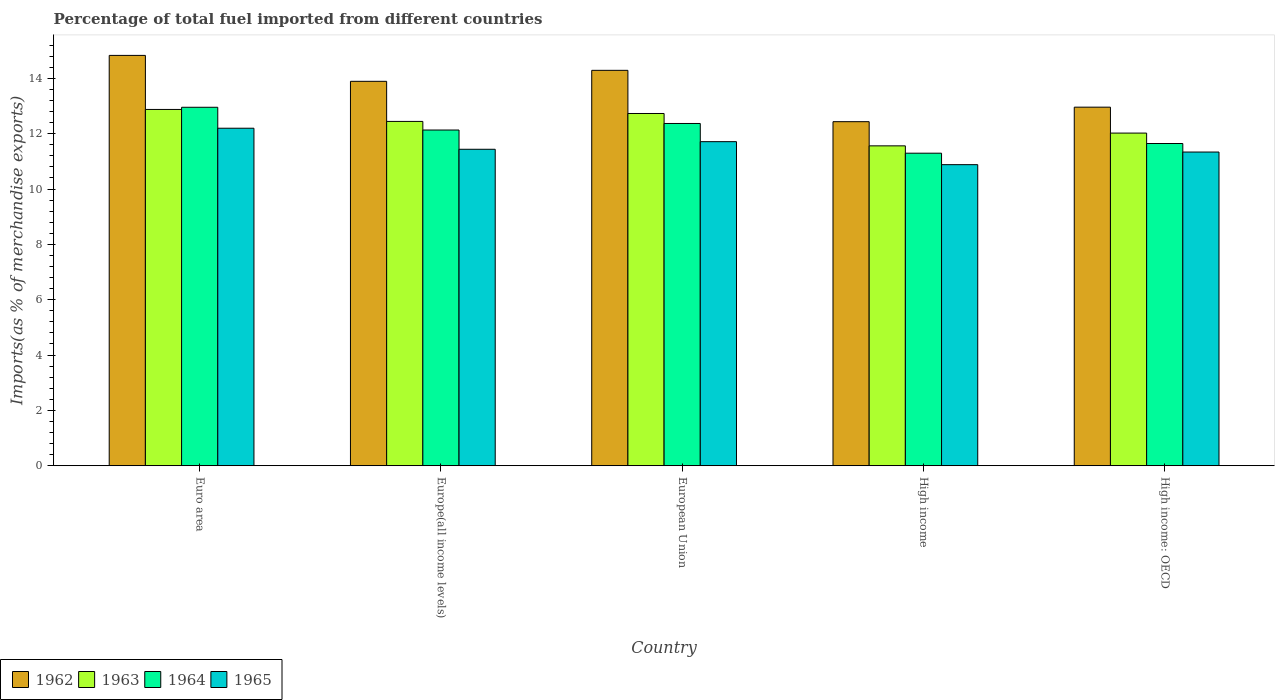How many groups of bars are there?
Make the answer very short. 5. Are the number of bars per tick equal to the number of legend labels?
Offer a terse response. Yes. What is the label of the 1st group of bars from the left?
Give a very brief answer. Euro area. In how many cases, is the number of bars for a given country not equal to the number of legend labels?
Provide a short and direct response. 0. What is the percentage of imports to different countries in 1964 in European Union?
Provide a succinct answer. 12.37. Across all countries, what is the maximum percentage of imports to different countries in 1965?
Provide a succinct answer. 12.2. Across all countries, what is the minimum percentage of imports to different countries in 1962?
Your response must be concise. 12.43. In which country was the percentage of imports to different countries in 1963 maximum?
Keep it short and to the point. Euro area. In which country was the percentage of imports to different countries in 1963 minimum?
Provide a short and direct response. High income. What is the total percentage of imports to different countries in 1964 in the graph?
Your response must be concise. 60.39. What is the difference between the percentage of imports to different countries in 1962 in European Union and that in High income: OECD?
Provide a succinct answer. 1.33. What is the difference between the percentage of imports to different countries in 1964 in Euro area and the percentage of imports to different countries in 1965 in High income: OECD?
Keep it short and to the point. 1.62. What is the average percentage of imports to different countries in 1962 per country?
Provide a succinct answer. 13.68. What is the difference between the percentage of imports to different countries of/in 1964 and percentage of imports to different countries of/in 1965 in High income: OECD?
Keep it short and to the point. 0.31. In how many countries, is the percentage of imports to different countries in 1963 greater than 12.4 %?
Your answer should be very brief. 3. What is the ratio of the percentage of imports to different countries in 1963 in High income to that in High income: OECD?
Your response must be concise. 0.96. What is the difference between the highest and the second highest percentage of imports to different countries in 1962?
Offer a terse response. -0.94. What is the difference between the highest and the lowest percentage of imports to different countries in 1965?
Make the answer very short. 1.32. What does the 3rd bar from the left in Euro area represents?
Your response must be concise. 1964. What does the 1st bar from the right in High income: OECD represents?
Provide a succinct answer. 1965. How many bars are there?
Ensure brevity in your answer.  20. How many countries are there in the graph?
Make the answer very short. 5. Does the graph contain any zero values?
Provide a short and direct response. No. Does the graph contain grids?
Ensure brevity in your answer.  No. Where does the legend appear in the graph?
Your response must be concise. Bottom left. How many legend labels are there?
Ensure brevity in your answer.  4. What is the title of the graph?
Your response must be concise. Percentage of total fuel imported from different countries. Does "2001" appear as one of the legend labels in the graph?
Offer a very short reply. No. What is the label or title of the Y-axis?
Your answer should be compact. Imports(as % of merchandise exports). What is the Imports(as % of merchandise exports) of 1962 in Euro area?
Ensure brevity in your answer.  14.83. What is the Imports(as % of merchandise exports) of 1963 in Euro area?
Ensure brevity in your answer.  12.88. What is the Imports(as % of merchandise exports) in 1964 in Euro area?
Keep it short and to the point. 12.95. What is the Imports(as % of merchandise exports) of 1965 in Euro area?
Your answer should be compact. 12.2. What is the Imports(as % of merchandise exports) in 1962 in Europe(all income levels)?
Keep it short and to the point. 13.89. What is the Imports(as % of merchandise exports) in 1963 in Europe(all income levels)?
Provide a short and direct response. 12.44. What is the Imports(as % of merchandise exports) in 1964 in Europe(all income levels)?
Give a very brief answer. 12.13. What is the Imports(as % of merchandise exports) in 1965 in Europe(all income levels)?
Your answer should be very brief. 11.44. What is the Imports(as % of merchandise exports) in 1962 in European Union?
Your answer should be very brief. 14.29. What is the Imports(as % of merchandise exports) in 1963 in European Union?
Make the answer very short. 12.73. What is the Imports(as % of merchandise exports) in 1964 in European Union?
Give a very brief answer. 12.37. What is the Imports(as % of merchandise exports) of 1965 in European Union?
Make the answer very short. 11.71. What is the Imports(as % of merchandise exports) of 1962 in High income?
Make the answer very short. 12.43. What is the Imports(as % of merchandise exports) of 1963 in High income?
Offer a terse response. 11.56. What is the Imports(as % of merchandise exports) in 1964 in High income?
Offer a terse response. 11.29. What is the Imports(as % of merchandise exports) in 1965 in High income?
Give a very brief answer. 10.88. What is the Imports(as % of merchandise exports) in 1962 in High income: OECD?
Provide a short and direct response. 12.96. What is the Imports(as % of merchandise exports) in 1963 in High income: OECD?
Your answer should be compact. 12.02. What is the Imports(as % of merchandise exports) in 1964 in High income: OECD?
Make the answer very short. 11.64. What is the Imports(as % of merchandise exports) in 1965 in High income: OECD?
Offer a terse response. 11.34. Across all countries, what is the maximum Imports(as % of merchandise exports) in 1962?
Make the answer very short. 14.83. Across all countries, what is the maximum Imports(as % of merchandise exports) of 1963?
Your answer should be compact. 12.88. Across all countries, what is the maximum Imports(as % of merchandise exports) in 1964?
Give a very brief answer. 12.95. Across all countries, what is the maximum Imports(as % of merchandise exports) of 1965?
Keep it short and to the point. 12.2. Across all countries, what is the minimum Imports(as % of merchandise exports) of 1962?
Your response must be concise. 12.43. Across all countries, what is the minimum Imports(as % of merchandise exports) of 1963?
Keep it short and to the point. 11.56. Across all countries, what is the minimum Imports(as % of merchandise exports) of 1964?
Ensure brevity in your answer.  11.29. Across all countries, what is the minimum Imports(as % of merchandise exports) of 1965?
Give a very brief answer. 10.88. What is the total Imports(as % of merchandise exports) of 1962 in the graph?
Make the answer very short. 68.4. What is the total Imports(as % of merchandise exports) of 1963 in the graph?
Provide a short and direct response. 61.63. What is the total Imports(as % of merchandise exports) in 1964 in the graph?
Offer a terse response. 60.39. What is the total Imports(as % of merchandise exports) in 1965 in the graph?
Ensure brevity in your answer.  57.56. What is the difference between the Imports(as % of merchandise exports) of 1962 in Euro area and that in Europe(all income levels)?
Your answer should be compact. 0.94. What is the difference between the Imports(as % of merchandise exports) of 1963 in Euro area and that in Europe(all income levels)?
Ensure brevity in your answer.  0.43. What is the difference between the Imports(as % of merchandise exports) in 1964 in Euro area and that in Europe(all income levels)?
Give a very brief answer. 0.82. What is the difference between the Imports(as % of merchandise exports) of 1965 in Euro area and that in Europe(all income levels)?
Keep it short and to the point. 0.76. What is the difference between the Imports(as % of merchandise exports) in 1962 in Euro area and that in European Union?
Ensure brevity in your answer.  0.54. What is the difference between the Imports(as % of merchandise exports) of 1963 in Euro area and that in European Union?
Provide a succinct answer. 0.15. What is the difference between the Imports(as % of merchandise exports) of 1964 in Euro area and that in European Union?
Offer a very short reply. 0.59. What is the difference between the Imports(as % of merchandise exports) in 1965 in Euro area and that in European Union?
Offer a very short reply. 0.49. What is the difference between the Imports(as % of merchandise exports) of 1962 in Euro area and that in High income?
Your answer should be compact. 2.4. What is the difference between the Imports(as % of merchandise exports) in 1963 in Euro area and that in High income?
Ensure brevity in your answer.  1.32. What is the difference between the Imports(as % of merchandise exports) of 1964 in Euro area and that in High income?
Provide a succinct answer. 1.66. What is the difference between the Imports(as % of merchandise exports) of 1965 in Euro area and that in High income?
Offer a terse response. 1.32. What is the difference between the Imports(as % of merchandise exports) of 1962 in Euro area and that in High income: OECD?
Make the answer very short. 1.87. What is the difference between the Imports(as % of merchandise exports) of 1963 in Euro area and that in High income: OECD?
Your response must be concise. 0.85. What is the difference between the Imports(as % of merchandise exports) in 1964 in Euro area and that in High income: OECD?
Ensure brevity in your answer.  1.31. What is the difference between the Imports(as % of merchandise exports) of 1965 in Euro area and that in High income: OECD?
Offer a terse response. 0.86. What is the difference between the Imports(as % of merchandise exports) of 1962 in Europe(all income levels) and that in European Union?
Offer a very short reply. -0.4. What is the difference between the Imports(as % of merchandise exports) in 1963 in Europe(all income levels) and that in European Union?
Your answer should be compact. -0.29. What is the difference between the Imports(as % of merchandise exports) of 1964 in Europe(all income levels) and that in European Union?
Provide a short and direct response. -0.24. What is the difference between the Imports(as % of merchandise exports) of 1965 in Europe(all income levels) and that in European Union?
Your response must be concise. -0.27. What is the difference between the Imports(as % of merchandise exports) in 1962 in Europe(all income levels) and that in High income?
Give a very brief answer. 1.46. What is the difference between the Imports(as % of merchandise exports) of 1963 in Europe(all income levels) and that in High income?
Your answer should be compact. 0.88. What is the difference between the Imports(as % of merchandise exports) of 1964 in Europe(all income levels) and that in High income?
Provide a succinct answer. 0.84. What is the difference between the Imports(as % of merchandise exports) in 1965 in Europe(all income levels) and that in High income?
Ensure brevity in your answer.  0.56. What is the difference between the Imports(as % of merchandise exports) in 1962 in Europe(all income levels) and that in High income: OECD?
Keep it short and to the point. 0.93. What is the difference between the Imports(as % of merchandise exports) in 1963 in Europe(all income levels) and that in High income: OECD?
Ensure brevity in your answer.  0.42. What is the difference between the Imports(as % of merchandise exports) of 1964 in Europe(all income levels) and that in High income: OECD?
Keep it short and to the point. 0.49. What is the difference between the Imports(as % of merchandise exports) in 1965 in Europe(all income levels) and that in High income: OECD?
Offer a terse response. 0.1. What is the difference between the Imports(as % of merchandise exports) of 1962 in European Union and that in High income?
Offer a very short reply. 1.86. What is the difference between the Imports(as % of merchandise exports) of 1963 in European Union and that in High income?
Your answer should be very brief. 1.17. What is the difference between the Imports(as % of merchandise exports) in 1964 in European Union and that in High income?
Give a very brief answer. 1.07. What is the difference between the Imports(as % of merchandise exports) of 1965 in European Union and that in High income?
Keep it short and to the point. 0.83. What is the difference between the Imports(as % of merchandise exports) in 1962 in European Union and that in High income: OECD?
Make the answer very short. 1.33. What is the difference between the Imports(as % of merchandise exports) of 1963 in European Union and that in High income: OECD?
Keep it short and to the point. 0.71. What is the difference between the Imports(as % of merchandise exports) in 1964 in European Union and that in High income: OECD?
Offer a very short reply. 0.72. What is the difference between the Imports(as % of merchandise exports) in 1965 in European Union and that in High income: OECD?
Provide a succinct answer. 0.38. What is the difference between the Imports(as % of merchandise exports) of 1962 in High income and that in High income: OECD?
Provide a short and direct response. -0.52. What is the difference between the Imports(as % of merchandise exports) in 1963 in High income and that in High income: OECD?
Your answer should be very brief. -0.46. What is the difference between the Imports(as % of merchandise exports) in 1964 in High income and that in High income: OECD?
Keep it short and to the point. -0.35. What is the difference between the Imports(as % of merchandise exports) in 1965 in High income and that in High income: OECD?
Give a very brief answer. -0.46. What is the difference between the Imports(as % of merchandise exports) of 1962 in Euro area and the Imports(as % of merchandise exports) of 1963 in Europe(all income levels)?
Provide a short and direct response. 2.39. What is the difference between the Imports(as % of merchandise exports) of 1962 in Euro area and the Imports(as % of merchandise exports) of 1964 in Europe(all income levels)?
Ensure brevity in your answer.  2.7. What is the difference between the Imports(as % of merchandise exports) of 1962 in Euro area and the Imports(as % of merchandise exports) of 1965 in Europe(all income levels)?
Provide a succinct answer. 3.39. What is the difference between the Imports(as % of merchandise exports) in 1963 in Euro area and the Imports(as % of merchandise exports) in 1964 in Europe(all income levels)?
Your answer should be very brief. 0.74. What is the difference between the Imports(as % of merchandise exports) in 1963 in Euro area and the Imports(as % of merchandise exports) in 1965 in Europe(all income levels)?
Your answer should be very brief. 1.44. What is the difference between the Imports(as % of merchandise exports) of 1964 in Euro area and the Imports(as % of merchandise exports) of 1965 in Europe(all income levels)?
Ensure brevity in your answer.  1.52. What is the difference between the Imports(as % of merchandise exports) in 1962 in Euro area and the Imports(as % of merchandise exports) in 1963 in European Union?
Offer a very short reply. 2.1. What is the difference between the Imports(as % of merchandise exports) in 1962 in Euro area and the Imports(as % of merchandise exports) in 1964 in European Union?
Your answer should be very brief. 2.46. What is the difference between the Imports(as % of merchandise exports) of 1962 in Euro area and the Imports(as % of merchandise exports) of 1965 in European Union?
Your response must be concise. 3.12. What is the difference between the Imports(as % of merchandise exports) of 1963 in Euro area and the Imports(as % of merchandise exports) of 1964 in European Union?
Provide a short and direct response. 0.51. What is the difference between the Imports(as % of merchandise exports) in 1963 in Euro area and the Imports(as % of merchandise exports) in 1965 in European Union?
Offer a terse response. 1.16. What is the difference between the Imports(as % of merchandise exports) in 1964 in Euro area and the Imports(as % of merchandise exports) in 1965 in European Union?
Your answer should be very brief. 1.24. What is the difference between the Imports(as % of merchandise exports) in 1962 in Euro area and the Imports(as % of merchandise exports) in 1963 in High income?
Ensure brevity in your answer.  3.27. What is the difference between the Imports(as % of merchandise exports) of 1962 in Euro area and the Imports(as % of merchandise exports) of 1964 in High income?
Your answer should be very brief. 3.53. What is the difference between the Imports(as % of merchandise exports) of 1962 in Euro area and the Imports(as % of merchandise exports) of 1965 in High income?
Ensure brevity in your answer.  3.95. What is the difference between the Imports(as % of merchandise exports) in 1963 in Euro area and the Imports(as % of merchandise exports) in 1964 in High income?
Make the answer very short. 1.58. What is the difference between the Imports(as % of merchandise exports) in 1963 in Euro area and the Imports(as % of merchandise exports) in 1965 in High income?
Give a very brief answer. 2. What is the difference between the Imports(as % of merchandise exports) in 1964 in Euro area and the Imports(as % of merchandise exports) in 1965 in High income?
Offer a terse response. 2.07. What is the difference between the Imports(as % of merchandise exports) in 1962 in Euro area and the Imports(as % of merchandise exports) in 1963 in High income: OECD?
Give a very brief answer. 2.81. What is the difference between the Imports(as % of merchandise exports) of 1962 in Euro area and the Imports(as % of merchandise exports) of 1964 in High income: OECD?
Offer a terse response. 3.18. What is the difference between the Imports(as % of merchandise exports) in 1962 in Euro area and the Imports(as % of merchandise exports) in 1965 in High income: OECD?
Offer a very short reply. 3.49. What is the difference between the Imports(as % of merchandise exports) in 1963 in Euro area and the Imports(as % of merchandise exports) in 1964 in High income: OECD?
Ensure brevity in your answer.  1.23. What is the difference between the Imports(as % of merchandise exports) in 1963 in Euro area and the Imports(as % of merchandise exports) in 1965 in High income: OECD?
Offer a terse response. 1.54. What is the difference between the Imports(as % of merchandise exports) in 1964 in Euro area and the Imports(as % of merchandise exports) in 1965 in High income: OECD?
Offer a terse response. 1.62. What is the difference between the Imports(as % of merchandise exports) of 1962 in Europe(all income levels) and the Imports(as % of merchandise exports) of 1963 in European Union?
Provide a short and direct response. 1.16. What is the difference between the Imports(as % of merchandise exports) of 1962 in Europe(all income levels) and the Imports(as % of merchandise exports) of 1964 in European Union?
Ensure brevity in your answer.  1.52. What is the difference between the Imports(as % of merchandise exports) in 1962 in Europe(all income levels) and the Imports(as % of merchandise exports) in 1965 in European Union?
Offer a very short reply. 2.18. What is the difference between the Imports(as % of merchandise exports) of 1963 in Europe(all income levels) and the Imports(as % of merchandise exports) of 1964 in European Union?
Offer a very short reply. 0.07. What is the difference between the Imports(as % of merchandise exports) in 1963 in Europe(all income levels) and the Imports(as % of merchandise exports) in 1965 in European Union?
Keep it short and to the point. 0.73. What is the difference between the Imports(as % of merchandise exports) in 1964 in Europe(all income levels) and the Imports(as % of merchandise exports) in 1965 in European Union?
Your answer should be very brief. 0.42. What is the difference between the Imports(as % of merchandise exports) of 1962 in Europe(all income levels) and the Imports(as % of merchandise exports) of 1963 in High income?
Your answer should be very brief. 2.33. What is the difference between the Imports(as % of merchandise exports) of 1962 in Europe(all income levels) and the Imports(as % of merchandise exports) of 1964 in High income?
Offer a very short reply. 2.6. What is the difference between the Imports(as % of merchandise exports) of 1962 in Europe(all income levels) and the Imports(as % of merchandise exports) of 1965 in High income?
Provide a short and direct response. 3.01. What is the difference between the Imports(as % of merchandise exports) in 1963 in Europe(all income levels) and the Imports(as % of merchandise exports) in 1964 in High income?
Ensure brevity in your answer.  1.15. What is the difference between the Imports(as % of merchandise exports) of 1963 in Europe(all income levels) and the Imports(as % of merchandise exports) of 1965 in High income?
Your answer should be compact. 1.56. What is the difference between the Imports(as % of merchandise exports) in 1964 in Europe(all income levels) and the Imports(as % of merchandise exports) in 1965 in High income?
Provide a succinct answer. 1.25. What is the difference between the Imports(as % of merchandise exports) in 1962 in Europe(all income levels) and the Imports(as % of merchandise exports) in 1963 in High income: OECD?
Ensure brevity in your answer.  1.87. What is the difference between the Imports(as % of merchandise exports) in 1962 in Europe(all income levels) and the Imports(as % of merchandise exports) in 1964 in High income: OECD?
Provide a short and direct response. 2.25. What is the difference between the Imports(as % of merchandise exports) of 1962 in Europe(all income levels) and the Imports(as % of merchandise exports) of 1965 in High income: OECD?
Give a very brief answer. 2.56. What is the difference between the Imports(as % of merchandise exports) of 1963 in Europe(all income levels) and the Imports(as % of merchandise exports) of 1964 in High income: OECD?
Keep it short and to the point. 0.8. What is the difference between the Imports(as % of merchandise exports) in 1963 in Europe(all income levels) and the Imports(as % of merchandise exports) in 1965 in High income: OECD?
Make the answer very short. 1.11. What is the difference between the Imports(as % of merchandise exports) of 1964 in Europe(all income levels) and the Imports(as % of merchandise exports) of 1965 in High income: OECD?
Make the answer very short. 0.8. What is the difference between the Imports(as % of merchandise exports) in 1962 in European Union and the Imports(as % of merchandise exports) in 1963 in High income?
Provide a succinct answer. 2.73. What is the difference between the Imports(as % of merchandise exports) in 1962 in European Union and the Imports(as % of merchandise exports) in 1964 in High income?
Ensure brevity in your answer.  2.99. What is the difference between the Imports(as % of merchandise exports) in 1962 in European Union and the Imports(as % of merchandise exports) in 1965 in High income?
Your answer should be very brief. 3.41. What is the difference between the Imports(as % of merchandise exports) in 1963 in European Union and the Imports(as % of merchandise exports) in 1964 in High income?
Make the answer very short. 1.43. What is the difference between the Imports(as % of merchandise exports) in 1963 in European Union and the Imports(as % of merchandise exports) in 1965 in High income?
Your answer should be compact. 1.85. What is the difference between the Imports(as % of merchandise exports) of 1964 in European Union and the Imports(as % of merchandise exports) of 1965 in High income?
Give a very brief answer. 1.49. What is the difference between the Imports(as % of merchandise exports) in 1962 in European Union and the Imports(as % of merchandise exports) in 1963 in High income: OECD?
Give a very brief answer. 2.27. What is the difference between the Imports(as % of merchandise exports) of 1962 in European Union and the Imports(as % of merchandise exports) of 1964 in High income: OECD?
Your answer should be compact. 2.64. What is the difference between the Imports(as % of merchandise exports) in 1962 in European Union and the Imports(as % of merchandise exports) in 1965 in High income: OECD?
Make the answer very short. 2.95. What is the difference between the Imports(as % of merchandise exports) in 1963 in European Union and the Imports(as % of merchandise exports) in 1964 in High income: OECD?
Ensure brevity in your answer.  1.08. What is the difference between the Imports(as % of merchandise exports) of 1963 in European Union and the Imports(as % of merchandise exports) of 1965 in High income: OECD?
Your response must be concise. 1.39. What is the difference between the Imports(as % of merchandise exports) of 1964 in European Union and the Imports(as % of merchandise exports) of 1965 in High income: OECD?
Keep it short and to the point. 1.03. What is the difference between the Imports(as % of merchandise exports) in 1962 in High income and the Imports(as % of merchandise exports) in 1963 in High income: OECD?
Provide a short and direct response. 0.41. What is the difference between the Imports(as % of merchandise exports) in 1962 in High income and the Imports(as % of merchandise exports) in 1964 in High income: OECD?
Your answer should be compact. 0.79. What is the difference between the Imports(as % of merchandise exports) of 1962 in High income and the Imports(as % of merchandise exports) of 1965 in High income: OECD?
Offer a terse response. 1.1. What is the difference between the Imports(as % of merchandise exports) of 1963 in High income and the Imports(as % of merchandise exports) of 1964 in High income: OECD?
Your response must be concise. -0.09. What is the difference between the Imports(as % of merchandise exports) of 1963 in High income and the Imports(as % of merchandise exports) of 1965 in High income: OECD?
Provide a succinct answer. 0.22. What is the difference between the Imports(as % of merchandise exports) in 1964 in High income and the Imports(as % of merchandise exports) in 1965 in High income: OECD?
Your answer should be very brief. -0.04. What is the average Imports(as % of merchandise exports) in 1962 per country?
Make the answer very short. 13.68. What is the average Imports(as % of merchandise exports) of 1963 per country?
Provide a short and direct response. 12.33. What is the average Imports(as % of merchandise exports) of 1964 per country?
Offer a very short reply. 12.08. What is the average Imports(as % of merchandise exports) in 1965 per country?
Provide a short and direct response. 11.51. What is the difference between the Imports(as % of merchandise exports) in 1962 and Imports(as % of merchandise exports) in 1963 in Euro area?
Ensure brevity in your answer.  1.95. What is the difference between the Imports(as % of merchandise exports) in 1962 and Imports(as % of merchandise exports) in 1964 in Euro area?
Your answer should be compact. 1.87. What is the difference between the Imports(as % of merchandise exports) of 1962 and Imports(as % of merchandise exports) of 1965 in Euro area?
Offer a very short reply. 2.63. What is the difference between the Imports(as % of merchandise exports) of 1963 and Imports(as % of merchandise exports) of 1964 in Euro area?
Offer a terse response. -0.08. What is the difference between the Imports(as % of merchandise exports) in 1963 and Imports(as % of merchandise exports) in 1965 in Euro area?
Offer a very short reply. 0.68. What is the difference between the Imports(as % of merchandise exports) of 1964 and Imports(as % of merchandise exports) of 1965 in Euro area?
Make the answer very short. 0.76. What is the difference between the Imports(as % of merchandise exports) in 1962 and Imports(as % of merchandise exports) in 1963 in Europe(all income levels)?
Offer a very short reply. 1.45. What is the difference between the Imports(as % of merchandise exports) of 1962 and Imports(as % of merchandise exports) of 1964 in Europe(all income levels)?
Your answer should be compact. 1.76. What is the difference between the Imports(as % of merchandise exports) of 1962 and Imports(as % of merchandise exports) of 1965 in Europe(all income levels)?
Offer a very short reply. 2.46. What is the difference between the Imports(as % of merchandise exports) in 1963 and Imports(as % of merchandise exports) in 1964 in Europe(all income levels)?
Your answer should be very brief. 0.31. What is the difference between the Imports(as % of merchandise exports) of 1963 and Imports(as % of merchandise exports) of 1965 in Europe(all income levels)?
Your answer should be very brief. 1.01. What is the difference between the Imports(as % of merchandise exports) of 1964 and Imports(as % of merchandise exports) of 1965 in Europe(all income levels)?
Offer a terse response. 0.7. What is the difference between the Imports(as % of merchandise exports) of 1962 and Imports(as % of merchandise exports) of 1963 in European Union?
Provide a short and direct response. 1.56. What is the difference between the Imports(as % of merchandise exports) in 1962 and Imports(as % of merchandise exports) in 1964 in European Union?
Make the answer very short. 1.92. What is the difference between the Imports(as % of merchandise exports) in 1962 and Imports(as % of merchandise exports) in 1965 in European Union?
Your answer should be very brief. 2.58. What is the difference between the Imports(as % of merchandise exports) in 1963 and Imports(as % of merchandise exports) in 1964 in European Union?
Your response must be concise. 0.36. What is the difference between the Imports(as % of merchandise exports) of 1963 and Imports(as % of merchandise exports) of 1965 in European Union?
Ensure brevity in your answer.  1.02. What is the difference between the Imports(as % of merchandise exports) of 1964 and Imports(as % of merchandise exports) of 1965 in European Union?
Ensure brevity in your answer.  0.66. What is the difference between the Imports(as % of merchandise exports) of 1962 and Imports(as % of merchandise exports) of 1963 in High income?
Keep it short and to the point. 0.87. What is the difference between the Imports(as % of merchandise exports) of 1962 and Imports(as % of merchandise exports) of 1964 in High income?
Offer a terse response. 1.14. What is the difference between the Imports(as % of merchandise exports) of 1962 and Imports(as % of merchandise exports) of 1965 in High income?
Your response must be concise. 1.55. What is the difference between the Imports(as % of merchandise exports) in 1963 and Imports(as % of merchandise exports) in 1964 in High income?
Your answer should be very brief. 0.27. What is the difference between the Imports(as % of merchandise exports) of 1963 and Imports(as % of merchandise exports) of 1965 in High income?
Your response must be concise. 0.68. What is the difference between the Imports(as % of merchandise exports) in 1964 and Imports(as % of merchandise exports) in 1965 in High income?
Make the answer very short. 0.41. What is the difference between the Imports(as % of merchandise exports) of 1962 and Imports(as % of merchandise exports) of 1963 in High income: OECD?
Give a very brief answer. 0.94. What is the difference between the Imports(as % of merchandise exports) in 1962 and Imports(as % of merchandise exports) in 1964 in High income: OECD?
Offer a very short reply. 1.31. What is the difference between the Imports(as % of merchandise exports) in 1962 and Imports(as % of merchandise exports) in 1965 in High income: OECD?
Your answer should be very brief. 1.62. What is the difference between the Imports(as % of merchandise exports) of 1963 and Imports(as % of merchandise exports) of 1964 in High income: OECD?
Your answer should be compact. 0.38. What is the difference between the Imports(as % of merchandise exports) of 1963 and Imports(as % of merchandise exports) of 1965 in High income: OECD?
Offer a terse response. 0.69. What is the difference between the Imports(as % of merchandise exports) in 1964 and Imports(as % of merchandise exports) in 1965 in High income: OECD?
Ensure brevity in your answer.  0.31. What is the ratio of the Imports(as % of merchandise exports) in 1962 in Euro area to that in Europe(all income levels)?
Offer a very short reply. 1.07. What is the ratio of the Imports(as % of merchandise exports) of 1963 in Euro area to that in Europe(all income levels)?
Provide a short and direct response. 1.03. What is the ratio of the Imports(as % of merchandise exports) in 1964 in Euro area to that in Europe(all income levels)?
Provide a short and direct response. 1.07. What is the ratio of the Imports(as % of merchandise exports) of 1965 in Euro area to that in Europe(all income levels)?
Your answer should be very brief. 1.07. What is the ratio of the Imports(as % of merchandise exports) of 1962 in Euro area to that in European Union?
Your response must be concise. 1.04. What is the ratio of the Imports(as % of merchandise exports) in 1963 in Euro area to that in European Union?
Keep it short and to the point. 1.01. What is the ratio of the Imports(as % of merchandise exports) in 1964 in Euro area to that in European Union?
Provide a succinct answer. 1.05. What is the ratio of the Imports(as % of merchandise exports) in 1965 in Euro area to that in European Union?
Provide a short and direct response. 1.04. What is the ratio of the Imports(as % of merchandise exports) in 1962 in Euro area to that in High income?
Provide a succinct answer. 1.19. What is the ratio of the Imports(as % of merchandise exports) of 1963 in Euro area to that in High income?
Ensure brevity in your answer.  1.11. What is the ratio of the Imports(as % of merchandise exports) in 1964 in Euro area to that in High income?
Your answer should be very brief. 1.15. What is the ratio of the Imports(as % of merchandise exports) of 1965 in Euro area to that in High income?
Offer a terse response. 1.12. What is the ratio of the Imports(as % of merchandise exports) in 1962 in Euro area to that in High income: OECD?
Your answer should be compact. 1.14. What is the ratio of the Imports(as % of merchandise exports) of 1963 in Euro area to that in High income: OECD?
Give a very brief answer. 1.07. What is the ratio of the Imports(as % of merchandise exports) in 1964 in Euro area to that in High income: OECD?
Offer a terse response. 1.11. What is the ratio of the Imports(as % of merchandise exports) of 1965 in Euro area to that in High income: OECD?
Your answer should be compact. 1.08. What is the ratio of the Imports(as % of merchandise exports) in 1962 in Europe(all income levels) to that in European Union?
Give a very brief answer. 0.97. What is the ratio of the Imports(as % of merchandise exports) of 1963 in Europe(all income levels) to that in European Union?
Make the answer very short. 0.98. What is the ratio of the Imports(as % of merchandise exports) of 1964 in Europe(all income levels) to that in European Union?
Offer a terse response. 0.98. What is the ratio of the Imports(as % of merchandise exports) of 1965 in Europe(all income levels) to that in European Union?
Keep it short and to the point. 0.98. What is the ratio of the Imports(as % of merchandise exports) in 1962 in Europe(all income levels) to that in High income?
Your answer should be compact. 1.12. What is the ratio of the Imports(as % of merchandise exports) in 1963 in Europe(all income levels) to that in High income?
Your answer should be compact. 1.08. What is the ratio of the Imports(as % of merchandise exports) in 1964 in Europe(all income levels) to that in High income?
Your answer should be very brief. 1.07. What is the ratio of the Imports(as % of merchandise exports) in 1965 in Europe(all income levels) to that in High income?
Offer a terse response. 1.05. What is the ratio of the Imports(as % of merchandise exports) in 1962 in Europe(all income levels) to that in High income: OECD?
Your response must be concise. 1.07. What is the ratio of the Imports(as % of merchandise exports) of 1963 in Europe(all income levels) to that in High income: OECD?
Make the answer very short. 1.04. What is the ratio of the Imports(as % of merchandise exports) in 1964 in Europe(all income levels) to that in High income: OECD?
Ensure brevity in your answer.  1.04. What is the ratio of the Imports(as % of merchandise exports) in 1965 in Europe(all income levels) to that in High income: OECD?
Offer a very short reply. 1.01. What is the ratio of the Imports(as % of merchandise exports) of 1962 in European Union to that in High income?
Your response must be concise. 1.15. What is the ratio of the Imports(as % of merchandise exports) of 1963 in European Union to that in High income?
Provide a short and direct response. 1.1. What is the ratio of the Imports(as % of merchandise exports) of 1964 in European Union to that in High income?
Your answer should be compact. 1.1. What is the ratio of the Imports(as % of merchandise exports) of 1965 in European Union to that in High income?
Your response must be concise. 1.08. What is the ratio of the Imports(as % of merchandise exports) of 1962 in European Union to that in High income: OECD?
Offer a terse response. 1.1. What is the ratio of the Imports(as % of merchandise exports) of 1963 in European Union to that in High income: OECD?
Give a very brief answer. 1.06. What is the ratio of the Imports(as % of merchandise exports) in 1964 in European Union to that in High income: OECD?
Provide a succinct answer. 1.06. What is the ratio of the Imports(as % of merchandise exports) of 1965 in European Union to that in High income: OECD?
Your answer should be compact. 1.03. What is the ratio of the Imports(as % of merchandise exports) in 1962 in High income to that in High income: OECD?
Your answer should be very brief. 0.96. What is the ratio of the Imports(as % of merchandise exports) in 1963 in High income to that in High income: OECD?
Make the answer very short. 0.96. What is the ratio of the Imports(as % of merchandise exports) in 1964 in High income to that in High income: OECD?
Offer a very short reply. 0.97. What is the ratio of the Imports(as % of merchandise exports) of 1965 in High income to that in High income: OECD?
Ensure brevity in your answer.  0.96. What is the difference between the highest and the second highest Imports(as % of merchandise exports) of 1962?
Offer a terse response. 0.54. What is the difference between the highest and the second highest Imports(as % of merchandise exports) in 1963?
Your answer should be very brief. 0.15. What is the difference between the highest and the second highest Imports(as % of merchandise exports) in 1964?
Keep it short and to the point. 0.59. What is the difference between the highest and the second highest Imports(as % of merchandise exports) in 1965?
Ensure brevity in your answer.  0.49. What is the difference between the highest and the lowest Imports(as % of merchandise exports) in 1962?
Your answer should be very brief. 2.4. What is the difference between the highest and the lowest Imports(as % of merchandise exports) in 1963?
Your answer should be compact. 1.32. What is the difference between the highest and the lowest Imports(as % of merchandise exports) in 1964?
Your response must be concise. 1.66. What is the difference between the highest and the lowest Imports(as % of merchandise exports) in 1965?
Offer a terse response. 1.32. 